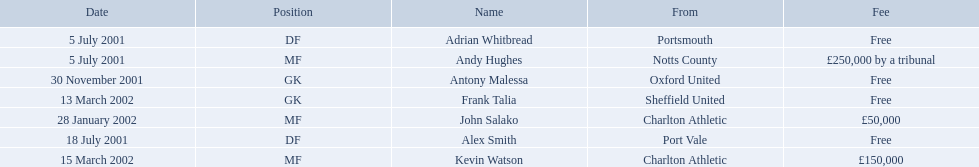What are all of the names? Andy Hughes, Adrian Whitbread, Alex Smith, Antony Malessa, John Salako, Frank Talia, Kevin Watson. What was the fee for each person? £250,000 by a tribunal, Free, Free, Free, £50,000, Free, £150,000. And who had the highest fee? Andy Hughes. 